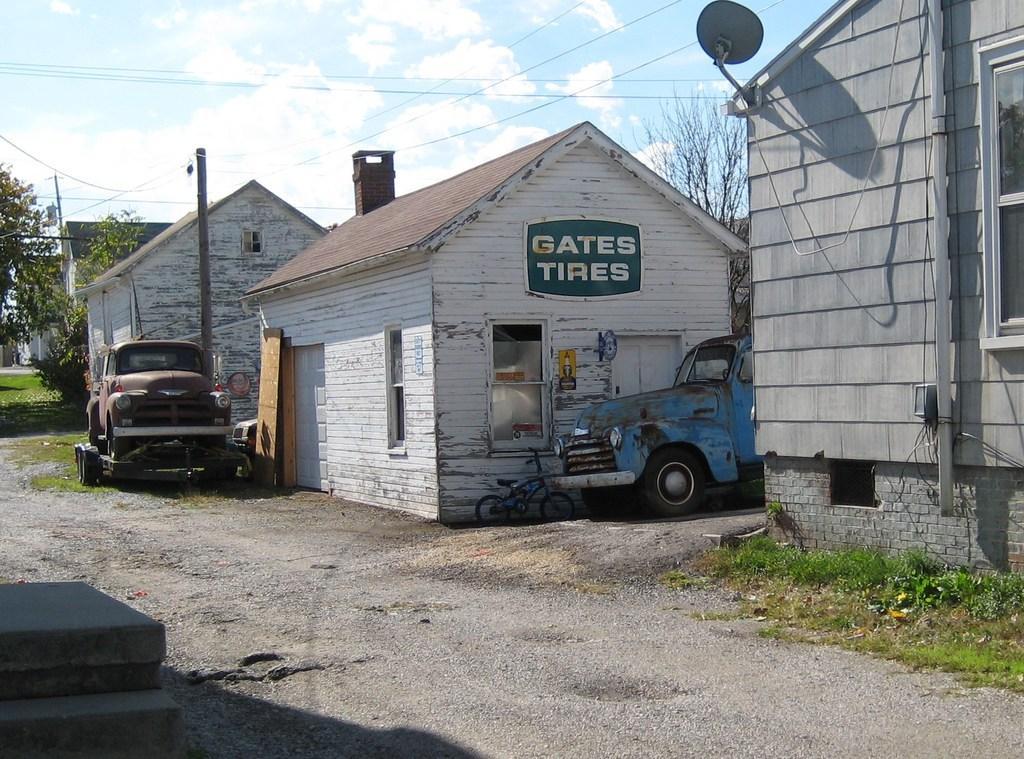Describe this image in one or two sentences. In this picture we can see houses here, there are two vehicles here, at the right bottom we can see grass, there is a satellite dish here, we can see a pole here, in the background there is a tree, we can see the sky at the top of the picture. 